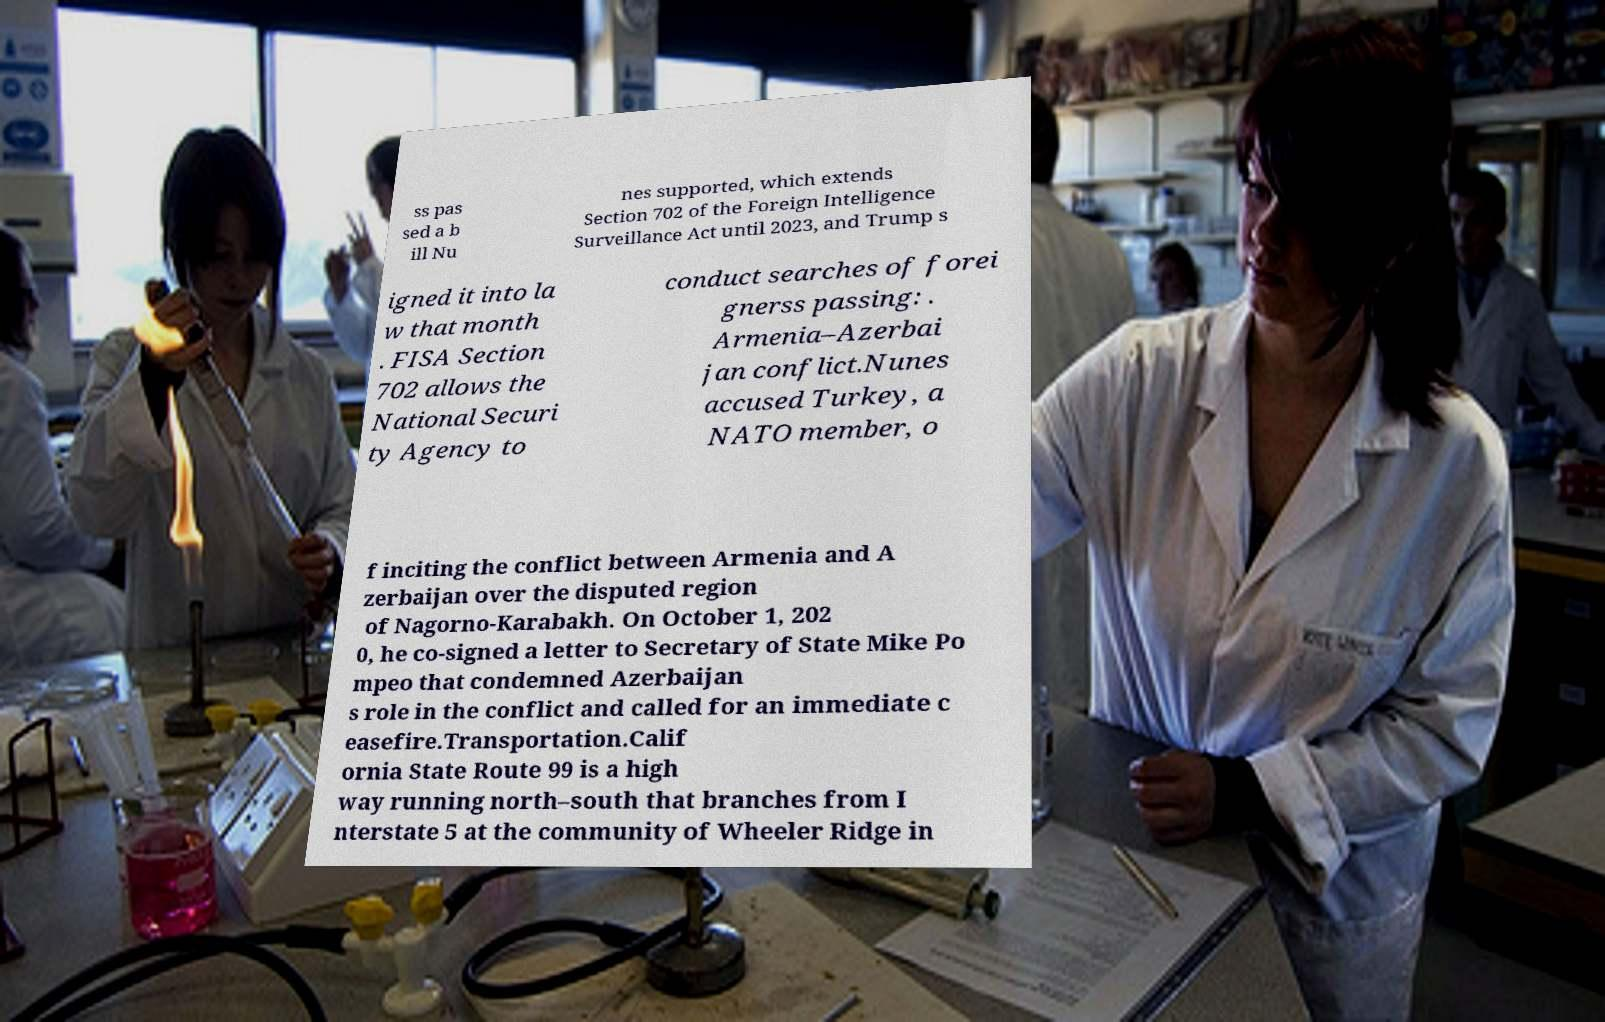I need the written content from this picture converted into text. Can you do that? ss pas sed a b ill Nu nes supported, which extends Section 702 of the Foreign Intelligence Surveillance Act until 2023, and Trump s igned it into la w that month . FISA Section 702 allows the National Securi ty Agency to conduct searches of forei gnerss passing: . Armenia–Azerbai jan conflict.Nunes accused Turkey, a NATO member, o f inciting the conflict between Armenia and A zerbaijan over the disputed region of Nagorno-Karabakh. On October 1, 202 0, he co-signed a letter to Secretary of State Mike Po mpeo that condemned Azerbaijan s role in the conflict and called for an immediate c easefire.Transportation.Calif ornia State Route 99 is a high way running north–south that branches from I nterstate 5 at the community of Wheeler Ridge in 